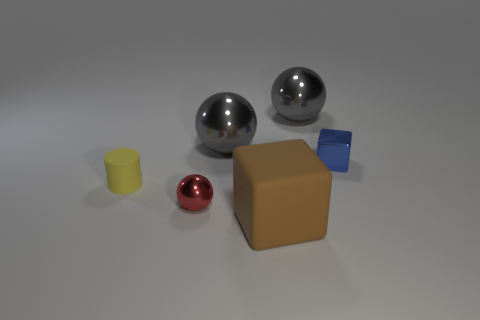What is the color of the sphere that is in front of the cube that is behind the small yellow cylinder?
Your answer should be compact. Red. Do the red object and the brown cube have the same size?
Make the answer very short. No. What number of blocks are either small blue shiny objects or large cyan metallic things?
Make the answer very short. 1. How many blue metallic things are left of the metallic thing that is in front of the small metallic block?
Keep it short and to the point. 0. Is the tiny blue thing the same shape as the large matte thing?
Offer a very short reply. Yes. What is the size of the other metal thing that is the same shape as the big brown object?
Your answer should be very brief. Small. What is the shape of the big object that is in front of the small shiny object that is behind the small yellow thing?
Make the answer very short. Cube. What is the size of the matte cylinder?
Provide a succinct answer. Small. What shape is the tiny red thing?
Keep it short and to the point. Sphere. There is a tiny red thing; does it have the same shape as the big object that is right of the brown cube?
Your response must be concise. Yes. 